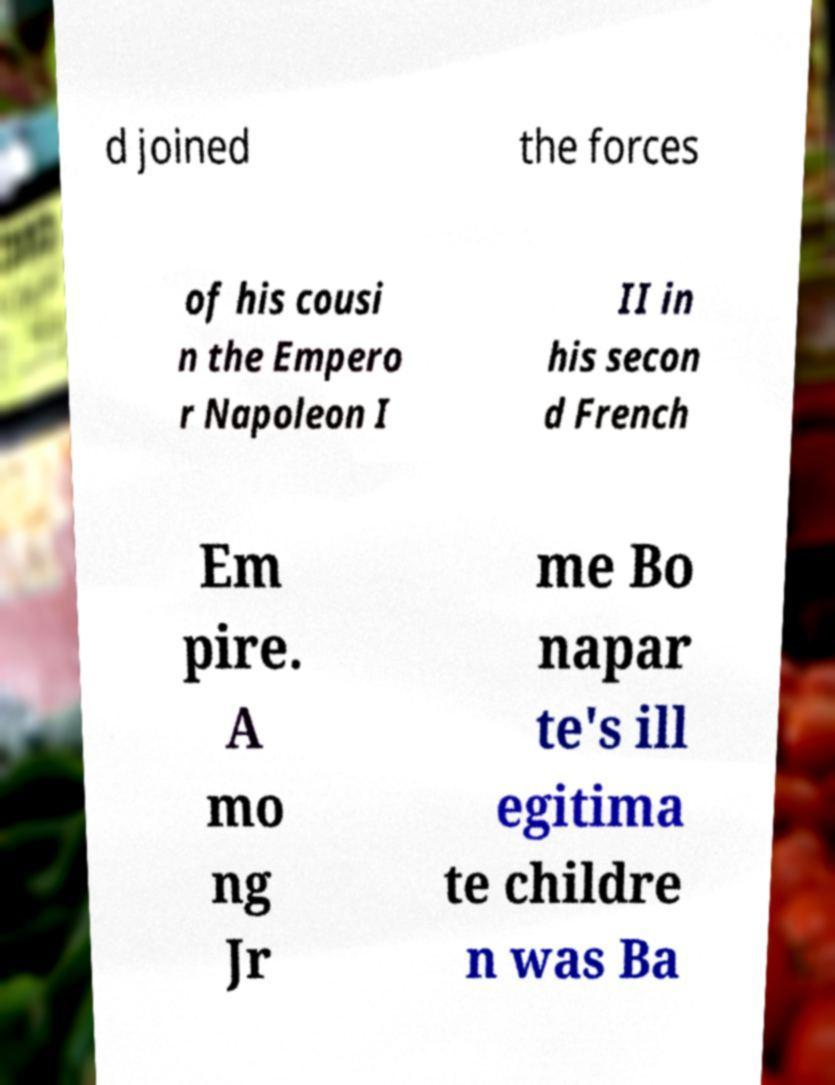Please identify and transcribe the text found in this image. d joined the forces of his cousi n the Empero r Napoleon I II in his secon d French Em pire. A mo ng Jr me Bo napar te's ill egitima te childre n was Ba 